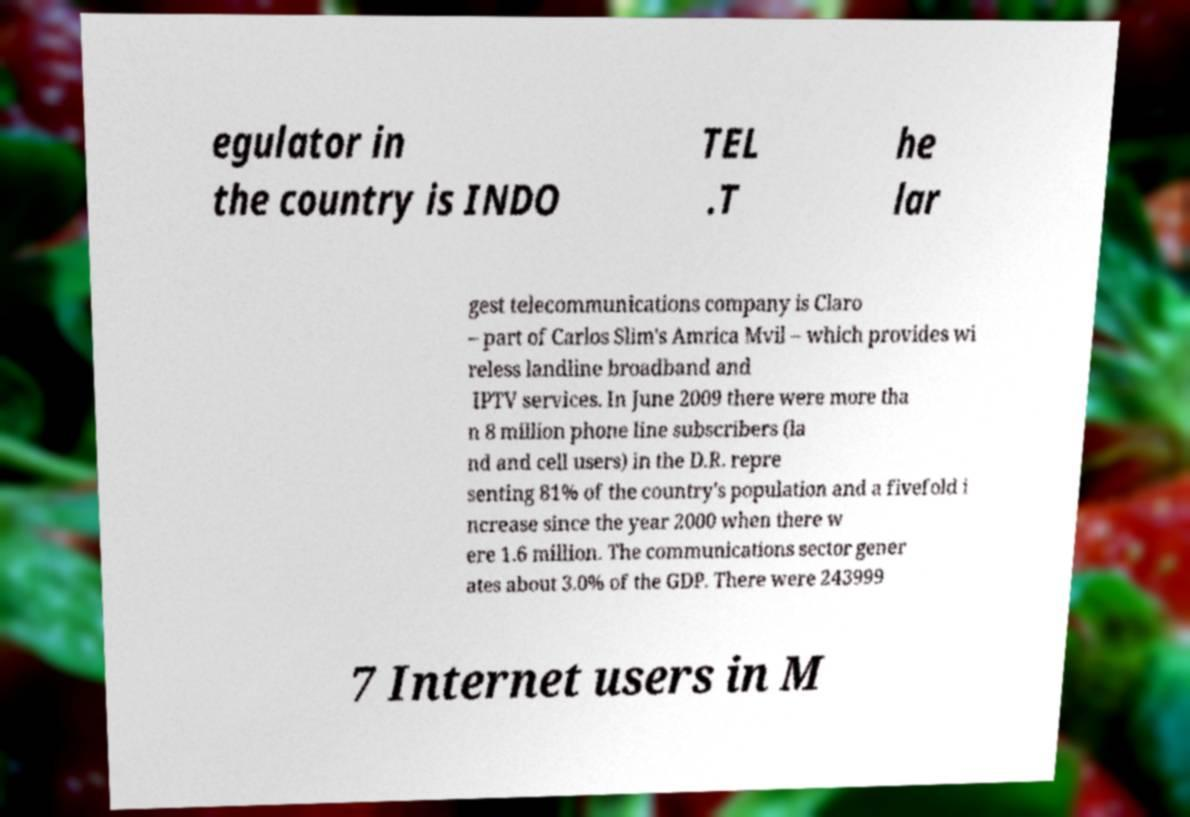For documentation purposes, I need the text within this image transcribed. Could you provide that? egulator in the country is INDO TEL .T he lar gest telecommunications company is Claro – part of Carlos Slim's Amrica Mvil – which provides wi reless landline broadband and IPTV services. In June 2009 there were more tha n 8 million phone line subscribers (la nd and cell users) in the D.R. repre senting 81% of the country's population and a fivefold i ncrease since the year 2000 when there w ere 1.6 million. The communications sector gener ates about 3.0% of the GDP. There were 243999 7 Internet users in M 